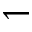Convert formula to latex. <formula><loc_0><loc_0><loc_500><loc_500>\leftharpoondown</formula> 